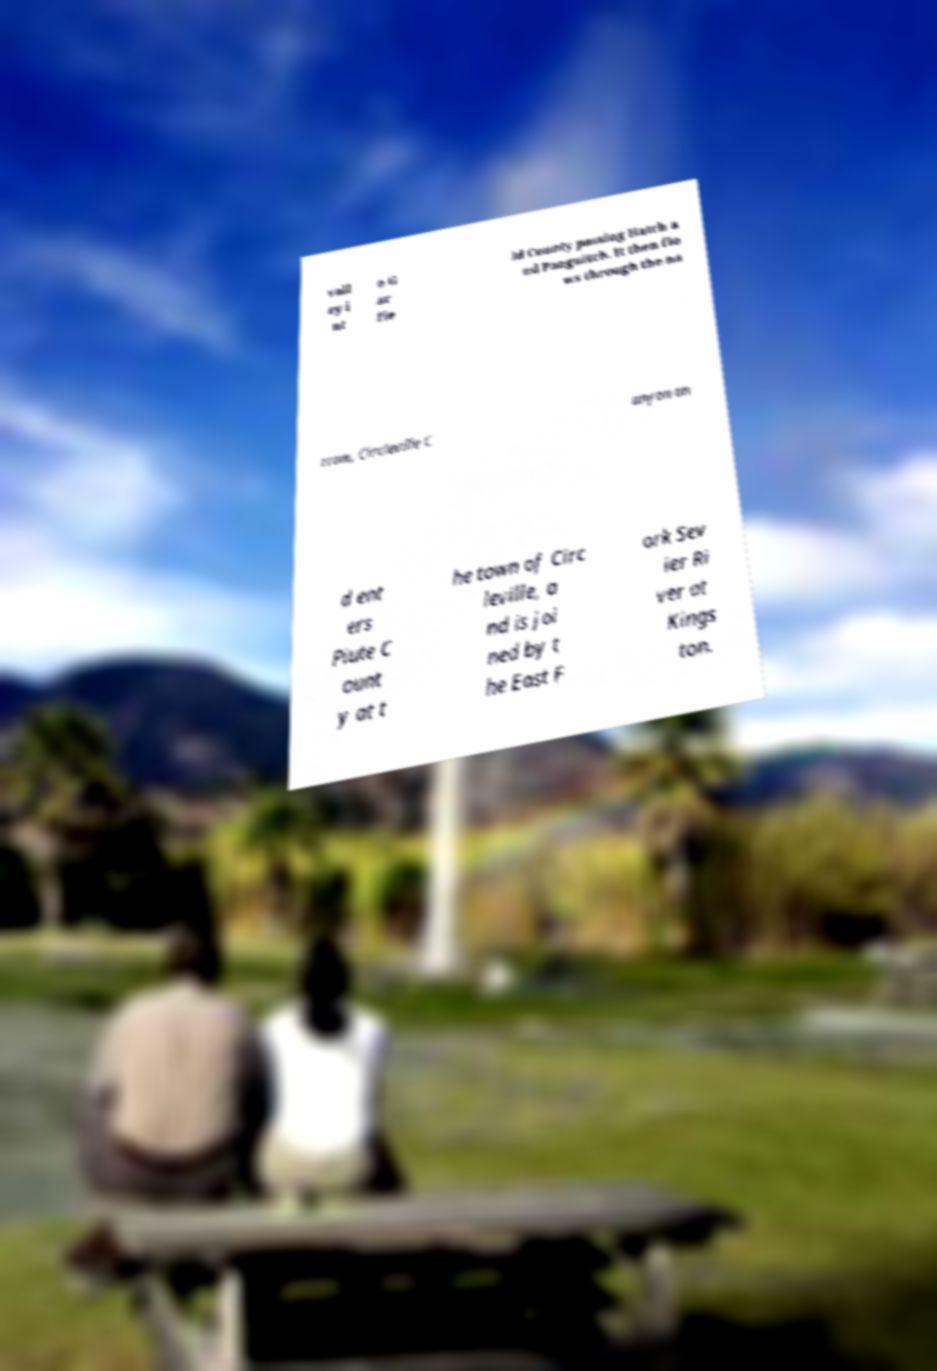Can you accurately transcribe the text from the provided image for me? vall ey i nt o G ar fie ld County passing Hatch a nd Panguitch. It then flo ws through the na rrow, Circleville C anyon an d ent ers Piute C ount y at t he town of Circ leville, a nd is joi ned by t he East F ork Sev ier Ri ver at Kings ton. 